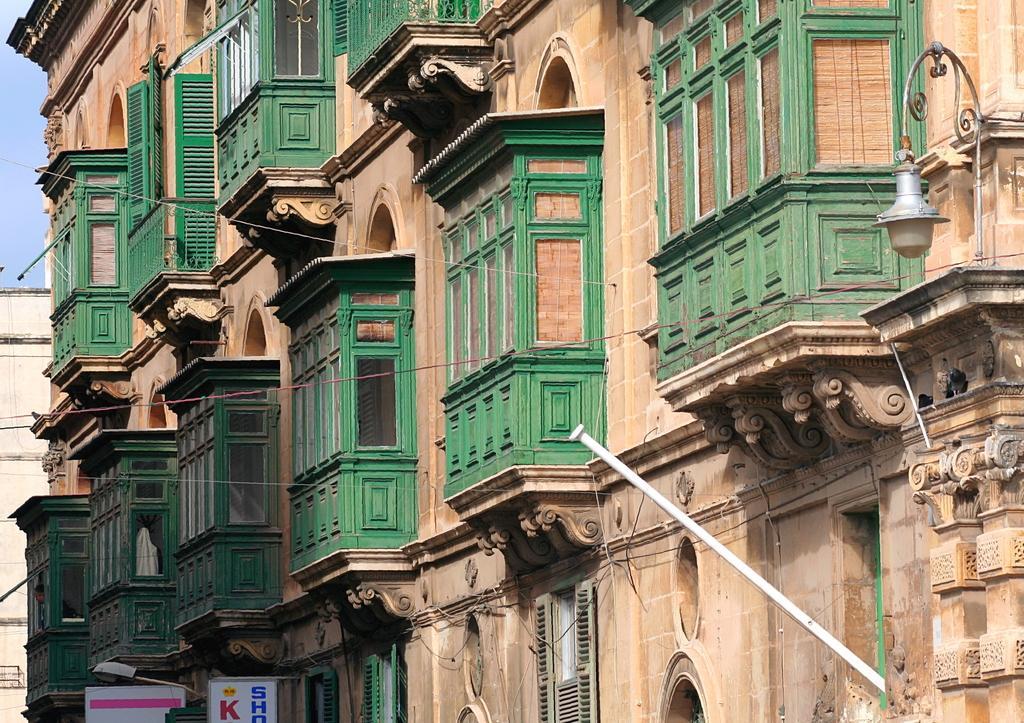Describe this image in one or two sentences. There are wires, a lamp at the right. There is a building which has green windows and there are boards at the bottom. 